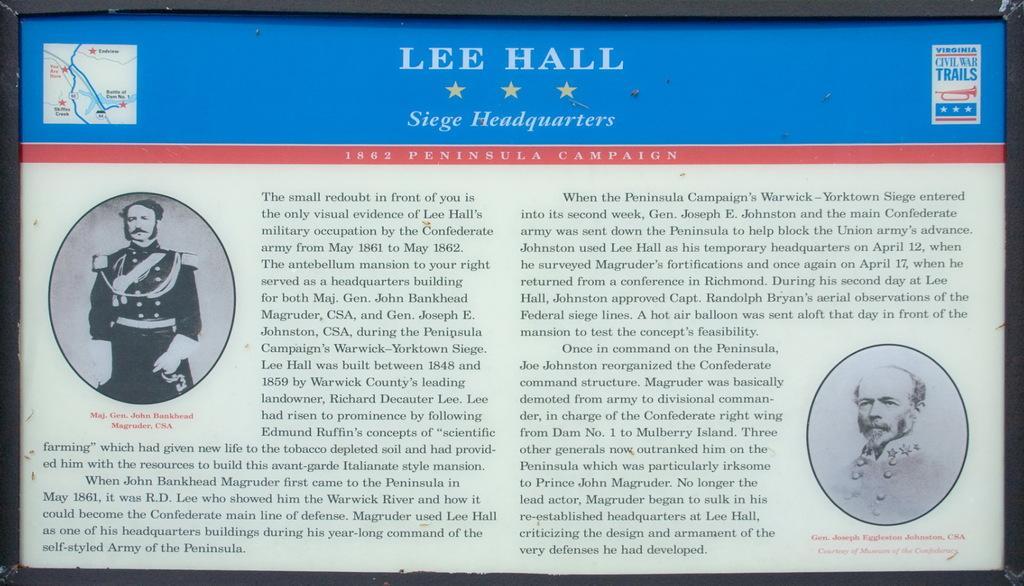Can you describe this image briefly? In this image, there is a power point presentation, on that at the top there is LEE HALL and SERGE HEADWATERS AND THERE ARE 3 STARS, there are some pictures and there is some text. 